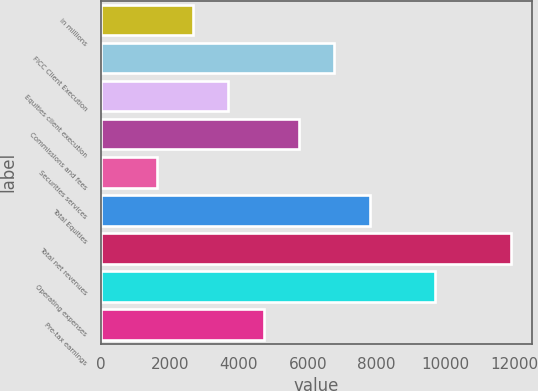Convert chart. <chart><loc_0><loc_0><loc_500><loc_500><bar_chart><fcel>in millions<fcel>FICC Client Execution<fcel>Equities client execution<fcel>Commissions and fees<fcel>Securities services<fcel>Total Equities<fcel>Total net revenues<fcel>Operating expenses<fcel>Pre-tax earnings<nl><fcel>2663.5<fcel>6769.5<fcel>3690<fcel>5743<fcel>1637<fcel>7796<fcel>11902<fcel>9692<fcel>4716.5<nl></chart> 